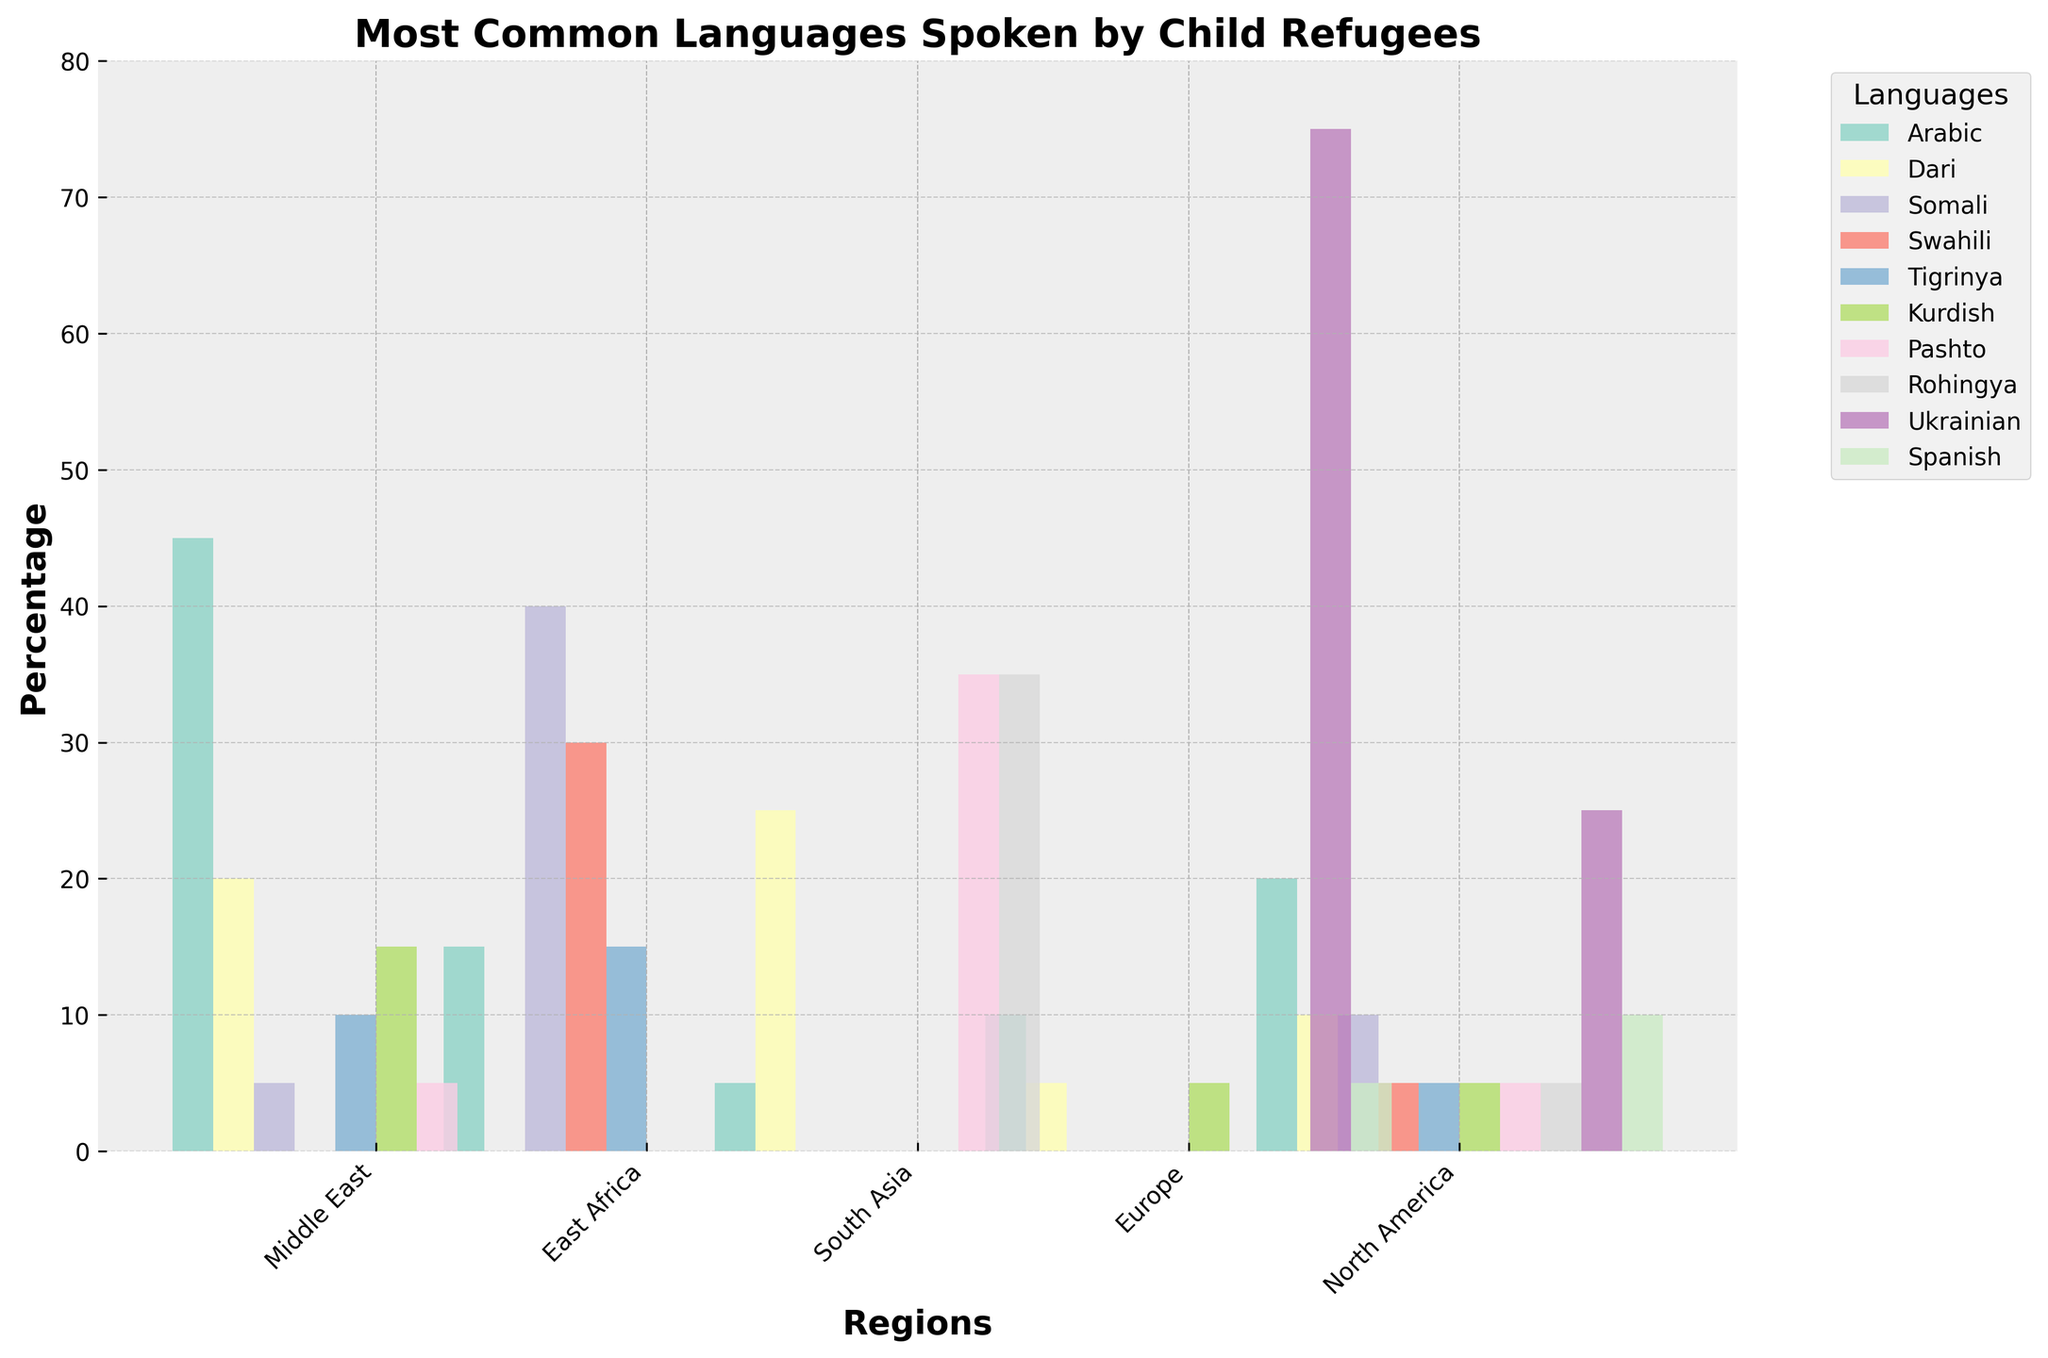What's the most common language spoken by child refugees in Middle East? The highest bar in the Middle East category is for Arabic.
Answer: Arabic How many regions have Ukrainian as a common language? Ukrainian appears in the data for Europe and North America. That's two regions.
Answer: 2 Which language has the highest percentage of child refugees in South Asia? The highest bar in the South Asia category is for both Pashto and Rohingya, at the same height.
Answer: Pashto and Rohingya What is the total percentage of Somali-speaking child refugees across all regions? Summing up the percentages of Somali-speaking child refugees in Middle East, East Africa, and North America gives 5 + 40 + 10 = 55.
Answer: 55 Which language is represented in all five regions? Checking each language, only Arabic is present in all regions.
Answer: Arabic What is the difference in Arabic-speaking child refugees between North America and East Africa? The percentage of Arabic-speaking child refugees in North America is 20 and in East Africa is 15. The difference is 20 - 15 = 5.
Answer: 5 Between Europe and North America, which region has a higher percentage of Spanish-speaking child refugees, and by how much? Europe has 5% and North America has 10% of Spanish-speaking child refugees. The difference is 10 - 5 = 5, with North America having more.
Answer: North America by 5% What is the average percentage of Tigrinya-speaking child refugees across the regions they are present in? Tigrinya is present in Middle East (10), East Africa (15), and North America (5). Average = (10 + 15 + 5)/3 = 10.
Answer: 10 Compare the percentage of Kurdish-speaking child refugees in Middle East and Europe. Which region has a higher percentage and by how much? Middle East has 15% and Europe has 5% of Kurdish-speaking child refugees. The difference is 15 - 5 = 10. Middle East has more.
Answer: Middle East by 10% In which regions is Swahili spoken, and what is the total percentage across those regions? Swahili is spoken in East Africa (30) and North America (5). Total percentage = 30 + 5 = 35.
Answer: East Africa and North America, 35 